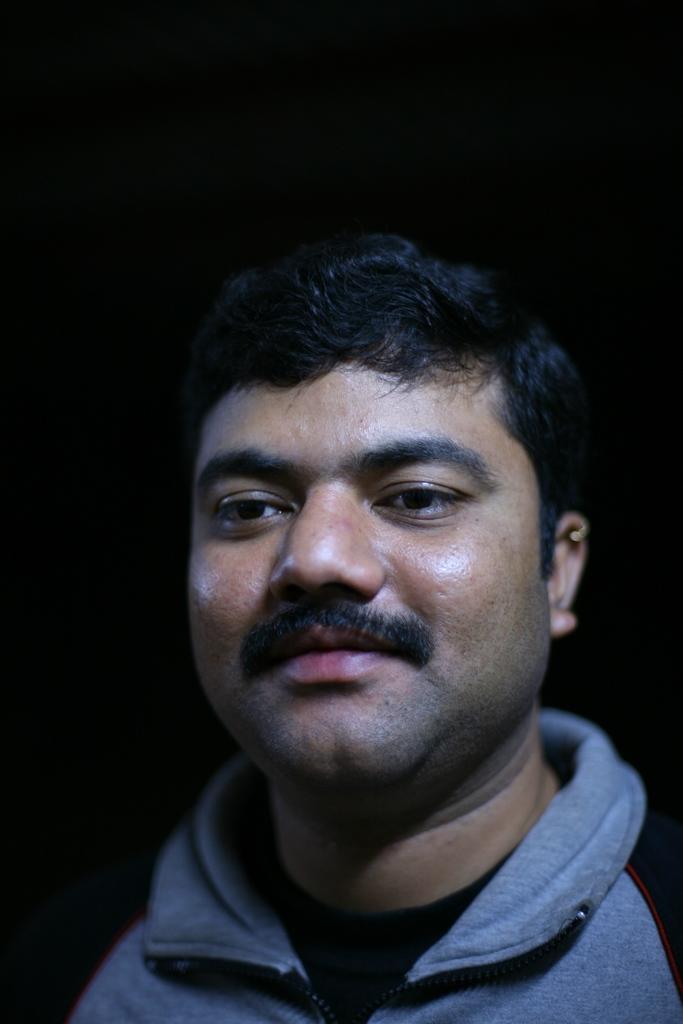Can you describe this image briefly? In the image there is a man in grey t-shirt smiling and the background is dark. 